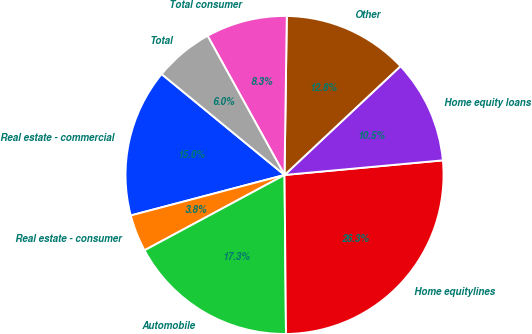Convert chart. <chart><loc_0><loc_0><loc_500><loc_500><pie_chart><fcel>Real estate - commercial<fcel>Real estate - consumer<fcel>Automobile<fcel>Home equitylines<fcel>Home equity loans<fcel>Other<fcel>Total consumer<fcel>Total<nl><fcel>15.04%<fcel>3.76%<fcel>17.29%<fcel>26.32%<fcel>10.53%<fcel>12.78%<fcel>8.27%<fcel>6.02%<nl></chart> 